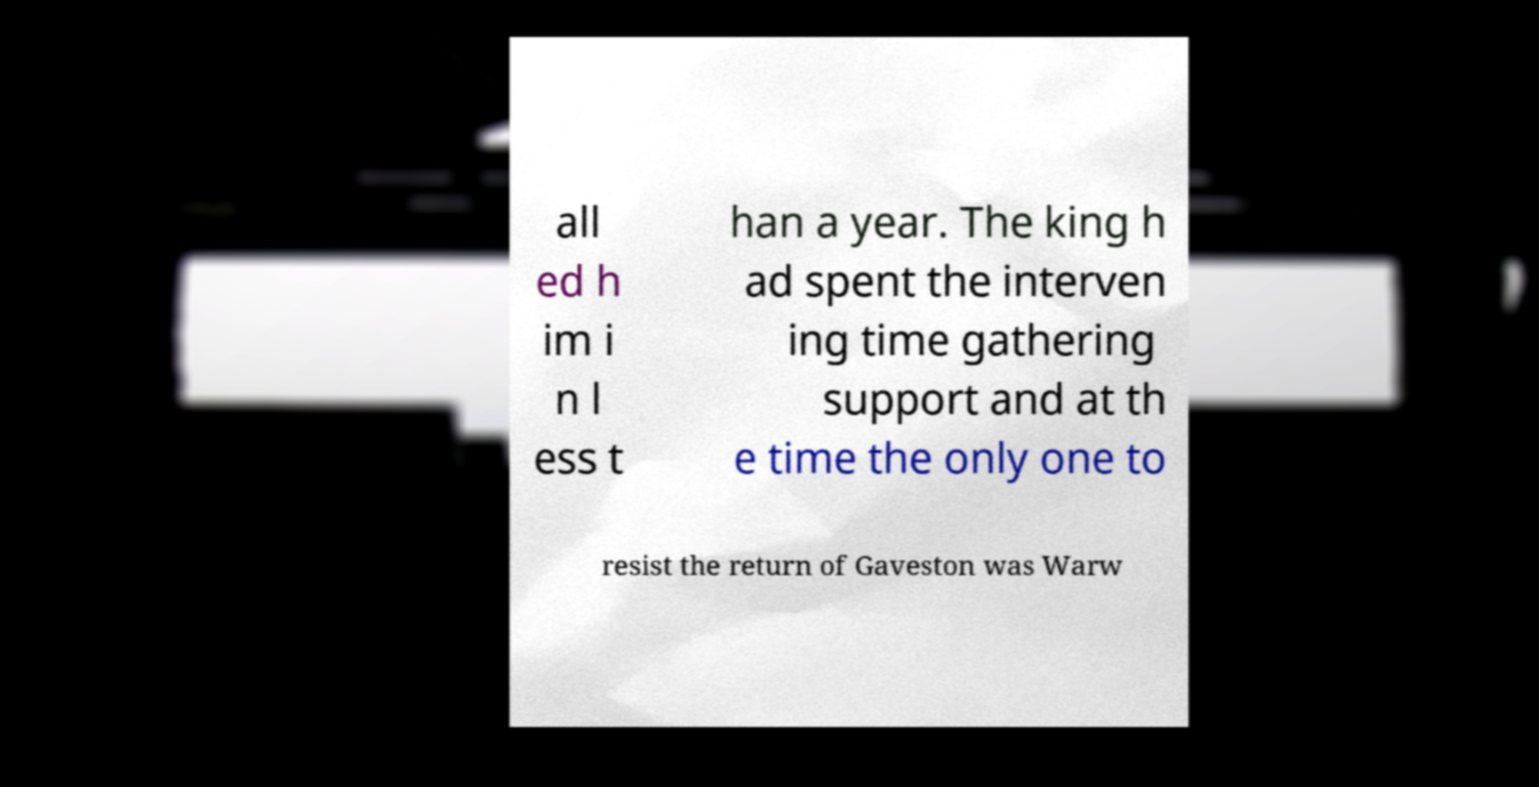Could you assist in decoding the text presented in this image and type it out clearly? all ed h im i n l ess t han a year. The king h ad spent the interven ing time gathering support and at th e time the only one to resist the return of Gaveston was Warw 